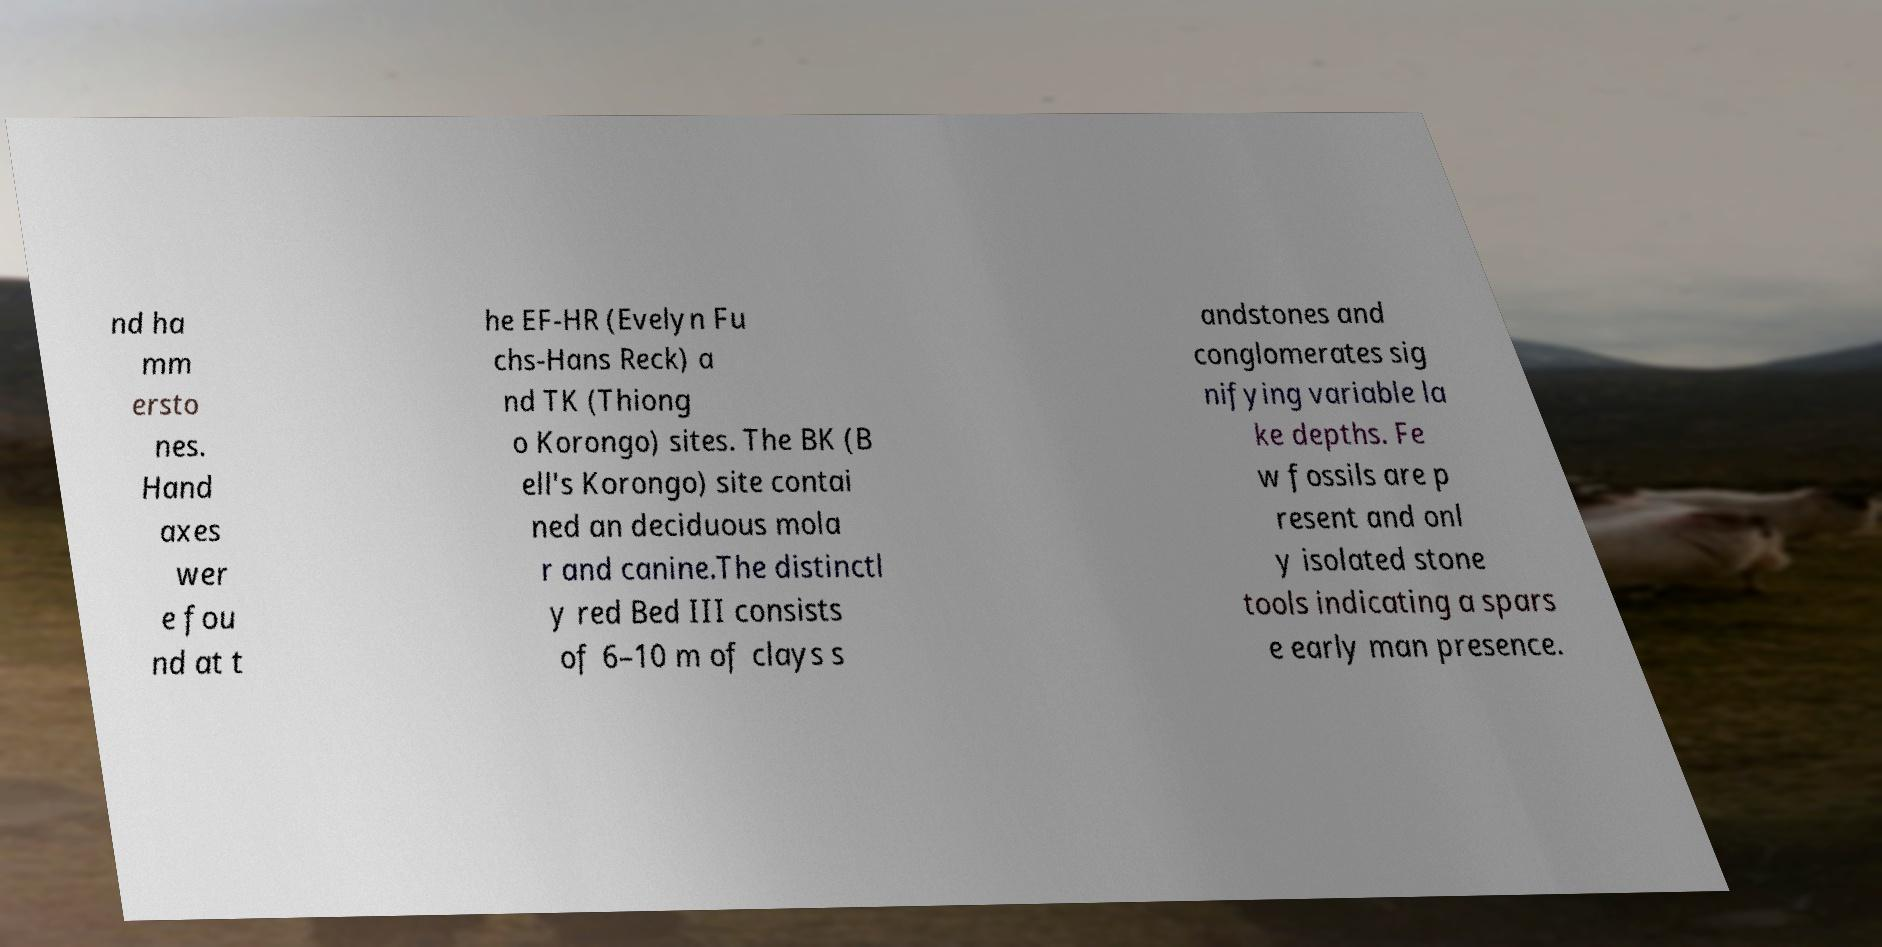Please read and relay the text visible in this image. What does it say? nd ha mm ersto nes. Hand axes wer e fou nd at t he EF-HR (Evelyn Fu chs-Hans Reck) a nd TK (Thiong o Korongo) sites. The BK (B ell's Korongo) site contai ned an deciduous mola r and canine.The distinctl y red Bed III consists of 6–10 m of clays s andstones and conglomerates sig nifying variable la ke depths. Fe w fossils are p resent and onl y isolated stone tools indicating a spars e early man presence. 